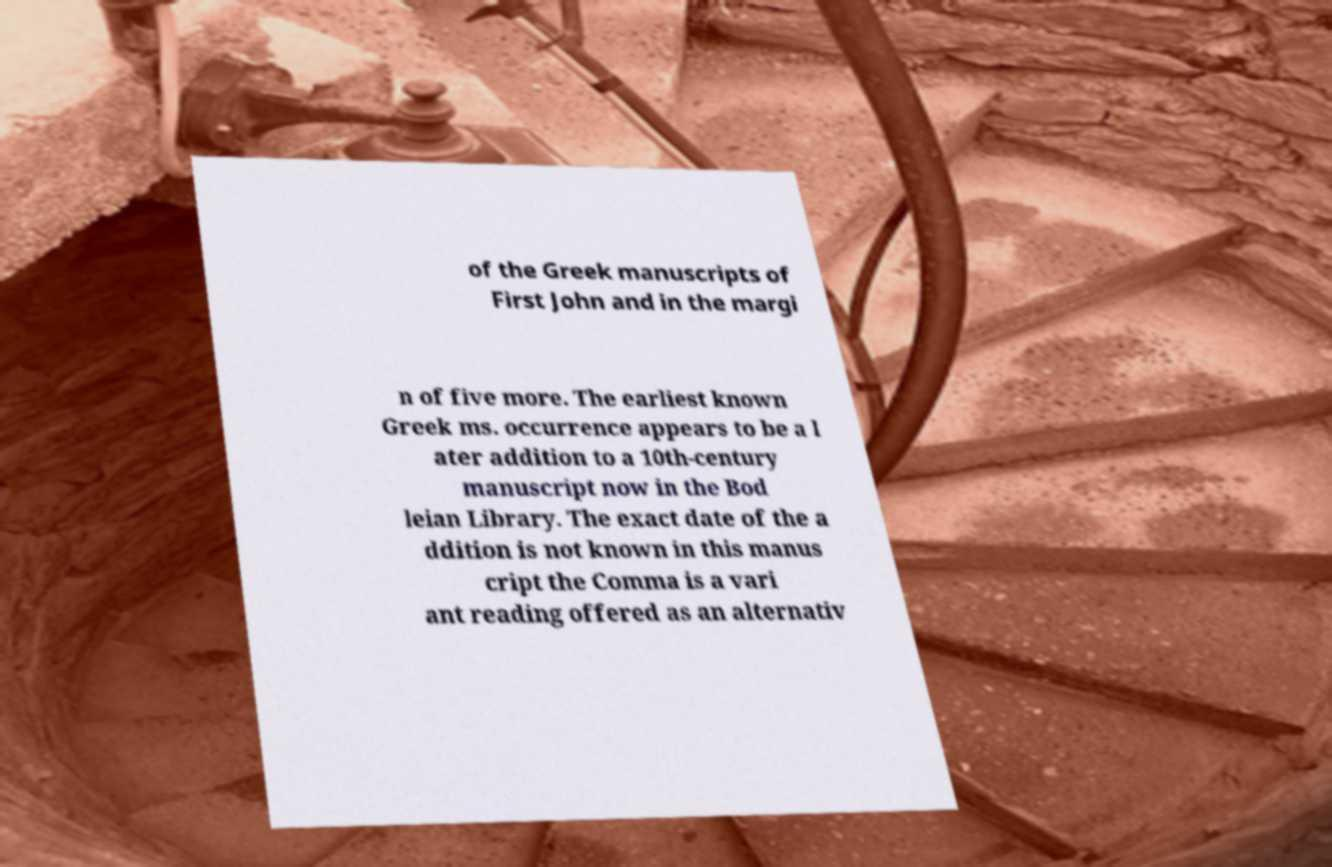Could you extract and type out the text from this image? of the Greek manuscripts of First John and in the margi n of five more. The earliest known Greek ms. occurrence appears to be a l ater addition to a 10th-century manuscript now in the Bod leian Library. The exact date of the a ddition is not known in this manus cript the Comma is a vari ant reading offered as an alternativ 